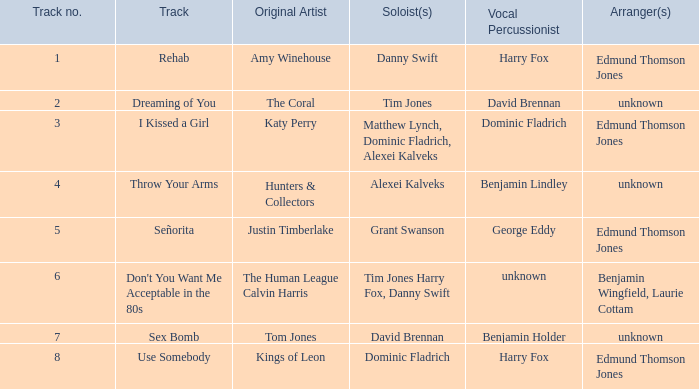Who is the vocal percussionist for Sex Bomb? Benjamin Holder. 